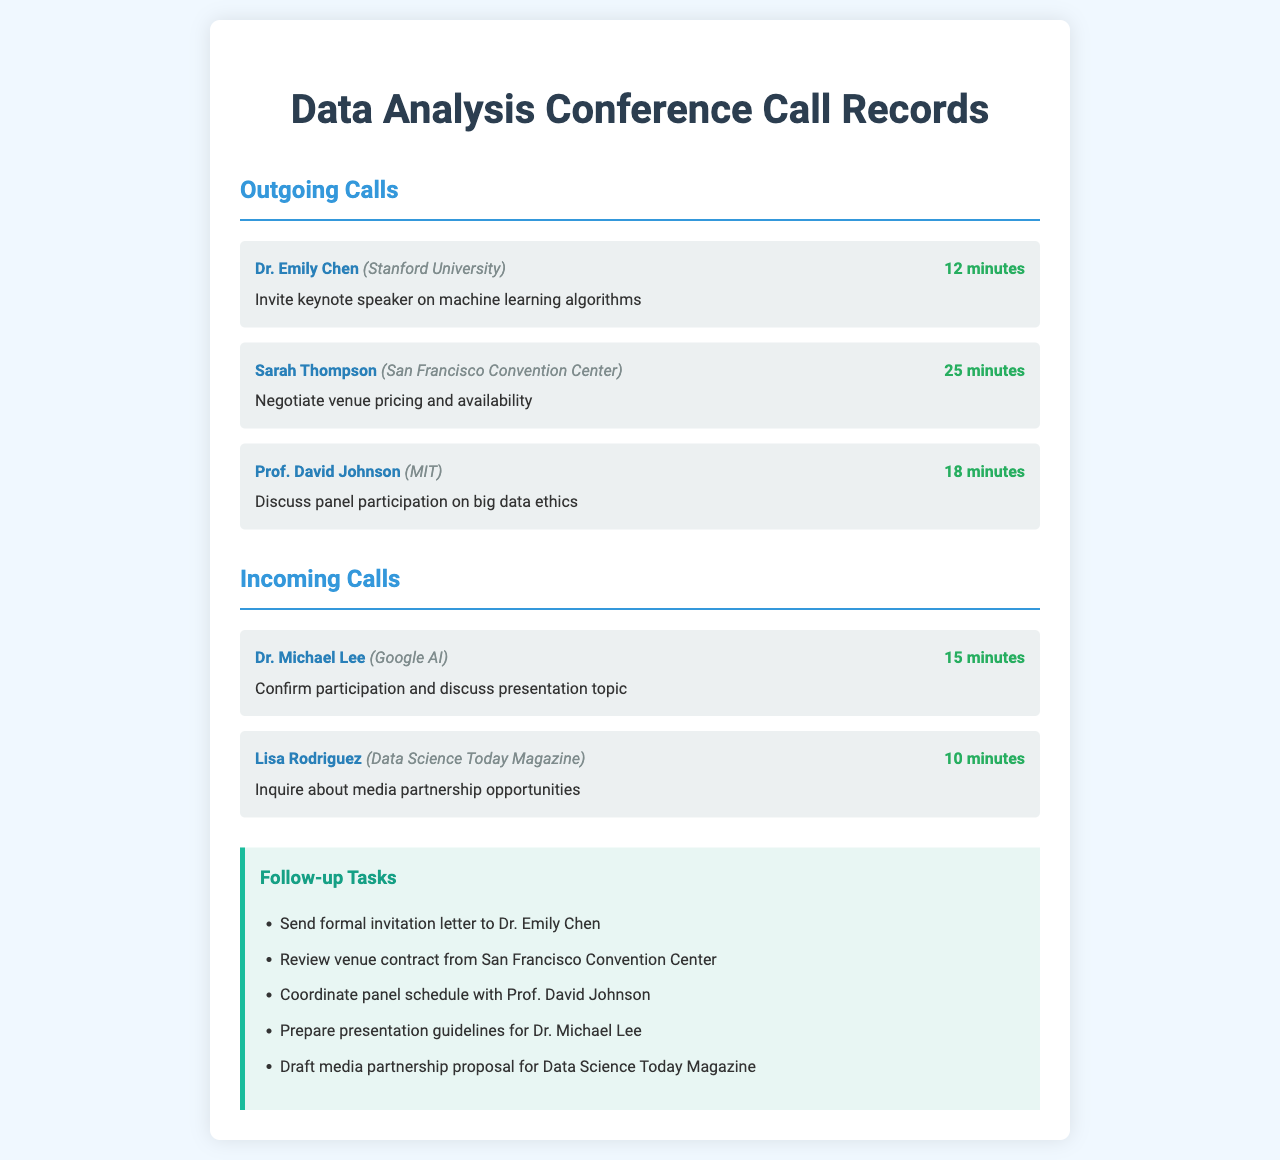What is the duration of the call with Dr. Emily Chen? The duration of the call with Dr. Emily Chen is stated in the document as 12 minutes.
Answer: 12 minutes Who did Sarah Thompson represent in the negotiations? Sarah Thompson is from the San Francisco Convention Center, as indicated in the call records.
Answer: San Francisco Convention Center What was the purpose of the call with Prof. David Johnson? The purpose is mentioned as discussing panel participation on big data ethics.
Answer: Discuss panel participation on big data ethics How many incoming calls are listed in the document? The document lists a total of two incoming calls under the Incoming Calls section.
Answer: 2 Which organization did Lisa Rodriguez represent? Lisa Rodriguez is associated with Data Science Today Magazine, as noted in the call records.
Answer: Data Science Today Magazine What task involves Dr. Michael Lee? The task for Dr. Michael Lee involves preparing presentation guidelines, as specified in the follow-up tasks.
Answer: Prepare presentation guidelines for Dr. Michael Lee What is the total number of follow-up tasks mentioned? There are five follow-up tasks enumerated in the document under the Follow-up Tasks section.
Answer: 5 What is the purpose of the call with Dr. Michael Lee? The purpose is to confirm participation and discuss presentation topic.
Answer: Confirm participation and discuss presentation topic Which speaker was invited as a keynote speaker? The document mentions Dr. Emily Chen as the invited keynote speaker on machine learning algorithms.
Answer: Dr. Emily Chen 